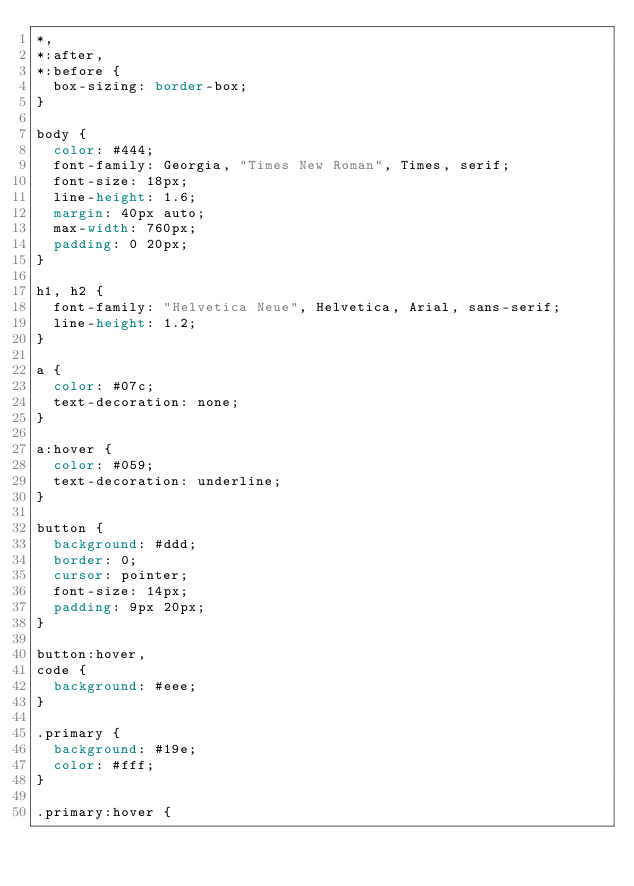Convert code to text. <code><loc_0><loc_0><loc_500><loc_500><_CSS_>*,
*:after,
*:before {
  box-sizing: border-box;
}

body {
  color: #444;
  font-family: Georgia, "Times New Roman", Times, serif;
  font-size: 18px;
  line-height: 1.6;
  margin: 40px auto;
  max-width: 760px;
  padding: 0 20px;
}

h1, h2 {
  font-family: "Helvetica Neue", Helvetica, Arial, sans-serif;
  line-height: 1.2;
}

a {
  color: #07c;
  text-decoration: none;
}

a:hover {
  color: #059;
  text-decoration: underline;
}

button {
  background: #ddd;
  border: 0;
  cursor: pointer;
  font-size: 14px;
  padding: 9px 20px;
}

button:hover,
code {
  background: #eee;
}

.primary {
  background: #19e;
  color: #fff;
}

.primary:hover {</code> 